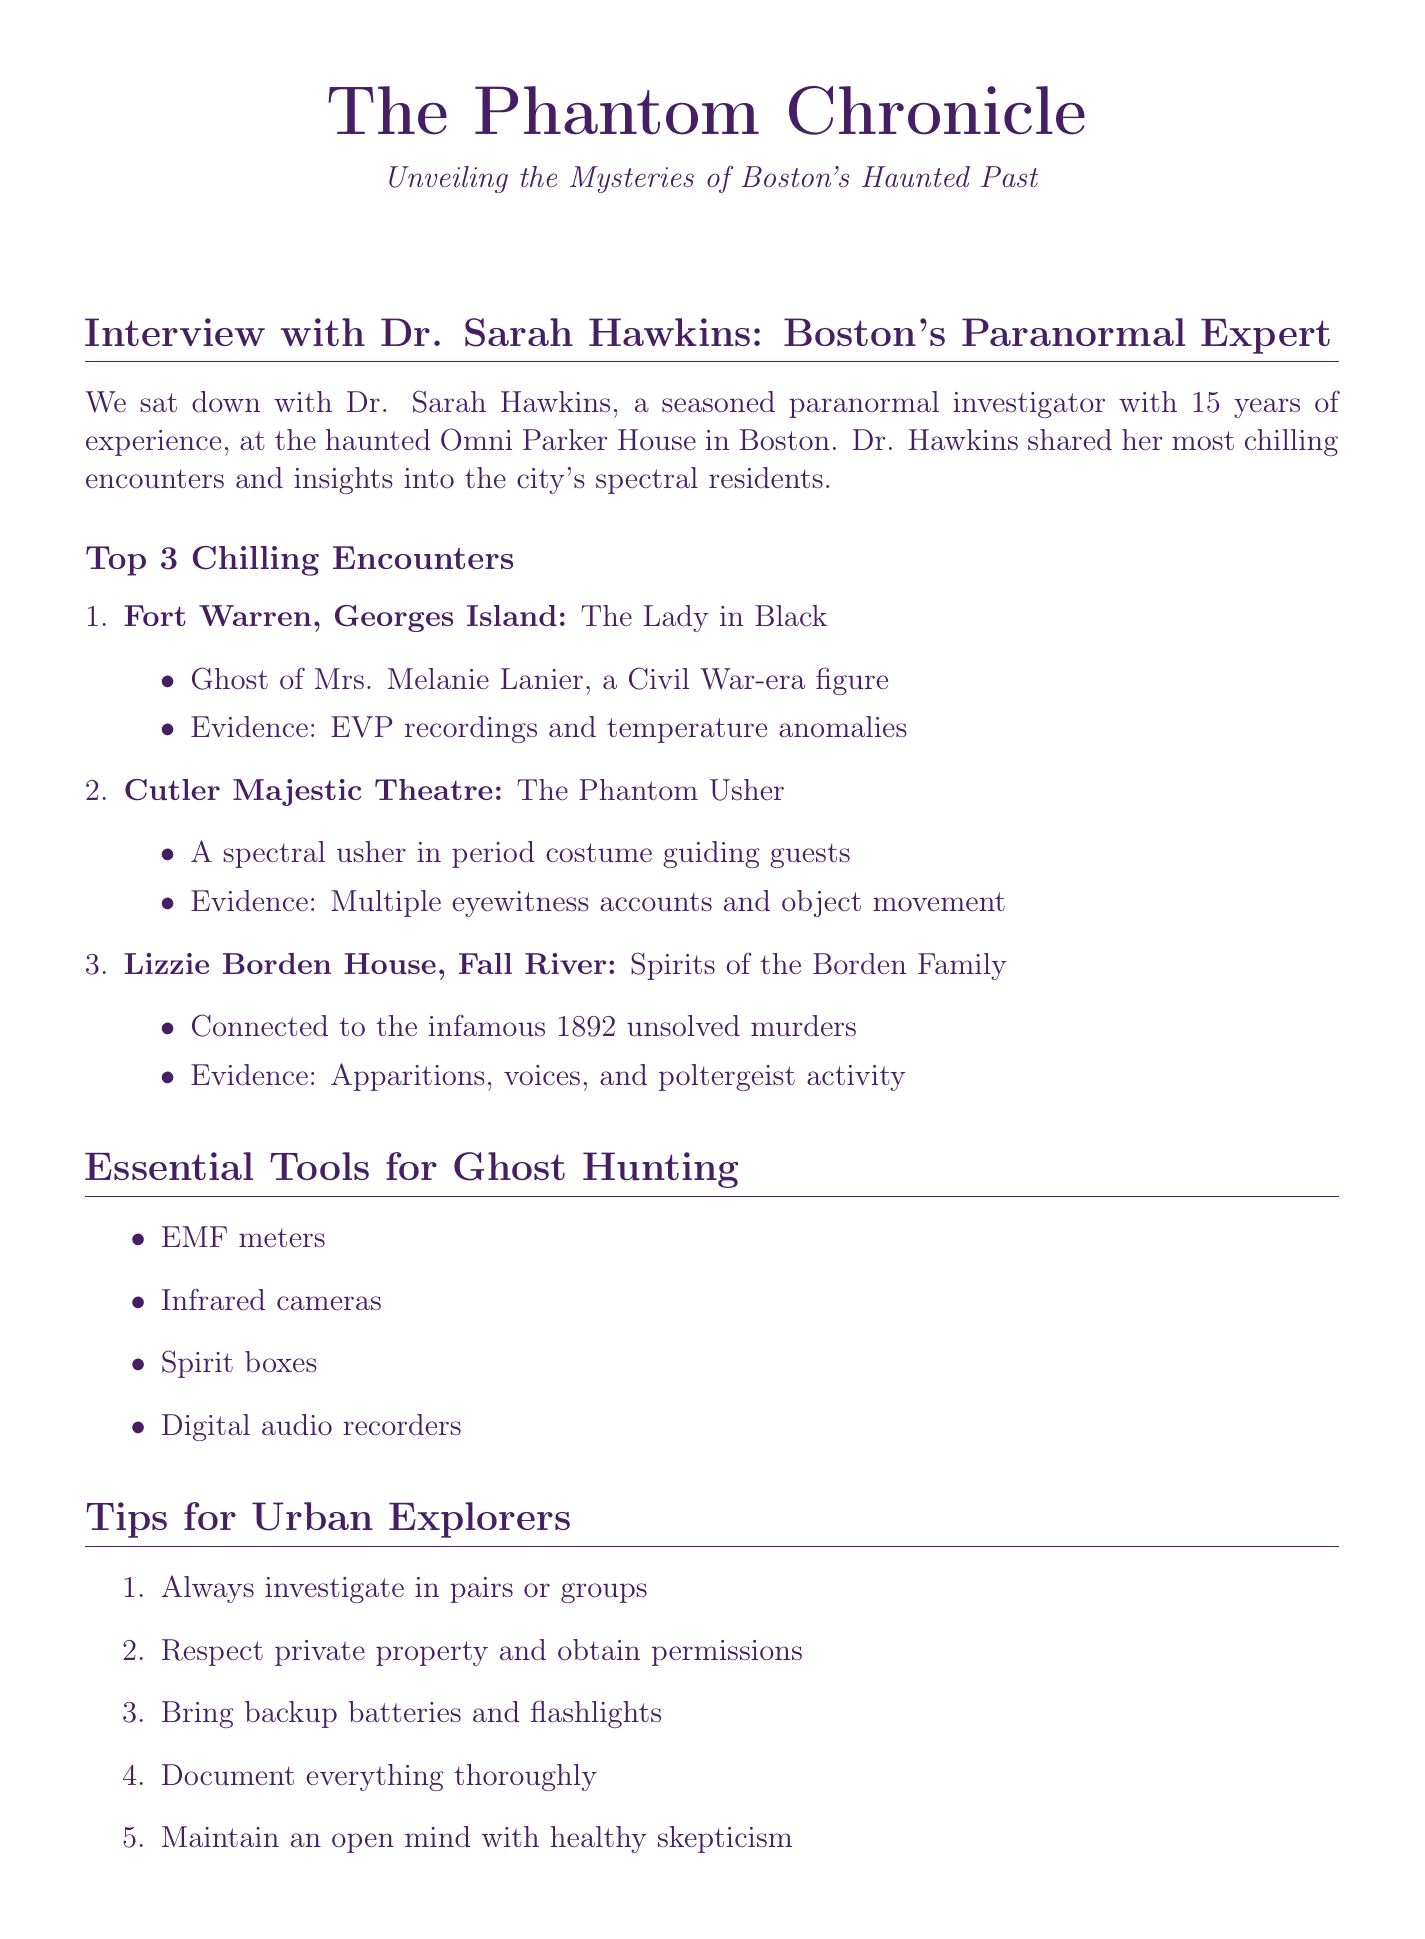What is the name of the paranormal investigator? The document states that the paranormal investigator is Dr. Sarah Hawkins.
Answer: Dr. Sarah Hawkins How long has Dr. Hawkins been investigating the paranormal? According to the document, Dr. Hawkins has 15 years of experience.
Answer: 15 years What hotel was the interview conducted in? The interview setting is The Omni Parker House, noted as one of Boston's most haunted hotels.
Answer: The Omni Parker House Which entity is associated with Fort Warren? The chilling encounter mentions The Lady in Black as the entity at Fort Warren.
Answer: The Lady in Black What is one tool used in paranormal investigations? The document lists several tools, with EMF meters being one example.
Answer: EMF meters What does the spectral usher do at the Cutler Majestic Theatre? The Phantom Usher appears to guide guests to their seats before vanishing.
Answer: Guides guests to their seats What phenomenon was reported at the USS Salem? Visitors and staff reported ghostly apparitions and unexplained noises.
Answer: Ghostly apparitions and unexplained noises What are the dates for the Paranormal Investigation Workshop? The workshop is scheduled for October 15-16.
Answer: October 15-16 What is a tip given for urban explorers? One of the tips suggests to always investigate in pairs or groups for safety.
Answer: Investigate in pairs or groups 